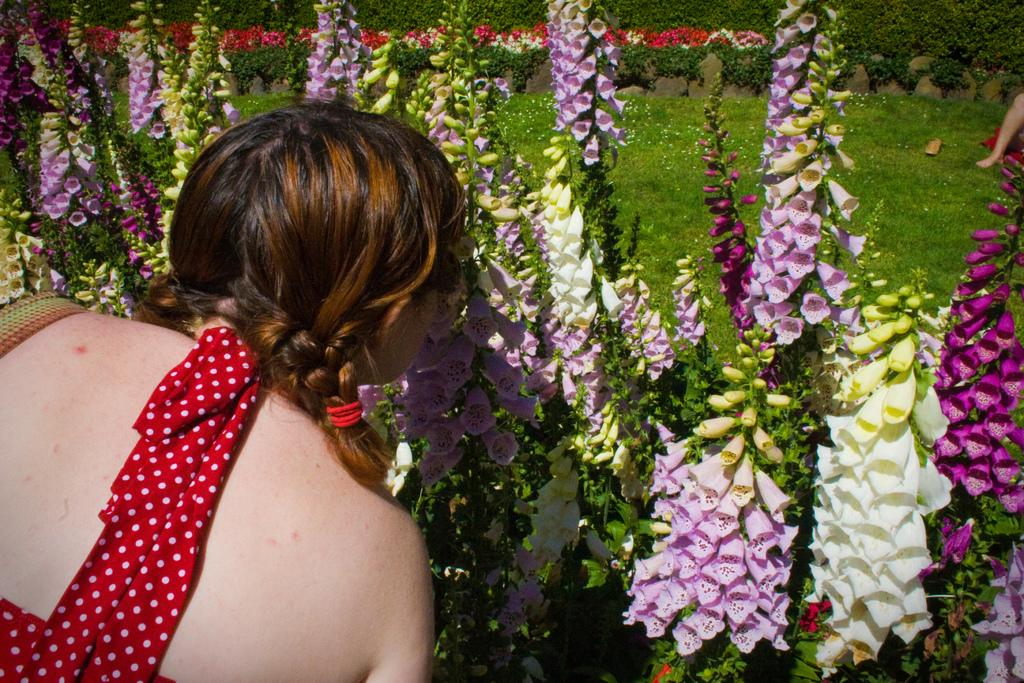What type of living organisms can be seen in the image? Plants and flowers are visible in the image. What is the person near the flowers doing? The person's leg is visible in the image, but their actions are not clear. What type of vegetation is present in the image? There is grass in the image. What type of powder is being used to lock the flowers in the image? There is no powder or lock present in the image; it features plants, flowers, and a person. How many cents are visible in the image? There are no coins or currency present in the image. 